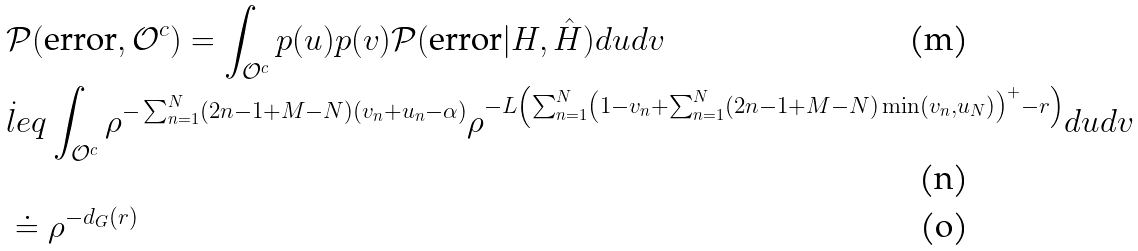<formula> <loc_0><loc_0><loc_500><loc_500>& \mathcal { P } ( \text {error} , \mathcal { O } ^ { c } ) = \int _ { \mathcal { O } ^ { c } } p ( u ) p ( v ) \mathcal { P } ( \text {error} | H , \hat { H } ) d u d v \\ & \dot { l } e q \int _ { \mathcal { O } ^ { c } } \rho ^ { - \sum _ { n = 1 } ^ { N } ( 2 n - 1 + M - N ) ( v _ { n } + u _ { n } - \alpha ) } \rho ^ { - L \left ( \sum _ { n = 1 } ^ { N } \left ( 1 - v _ { n } + \sum _ { n = 1 } ^ { N } ( 2 n - 1 + M - N ) \min ( v _ { n } , u _ { N } ) \right ) ^ { + } - r \right ) } d u d v \\ & \doteq \rho ^ { - d _ { G } ( r ) }</formula> 